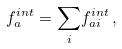Convert formula to latex. <formula><loc_0><loc_0><loc_500><loc_500>f _ { a } ^ { i n t } = \underset { i } { \sum } f _ { a i } ^ { i n t } \, ,</formula> 